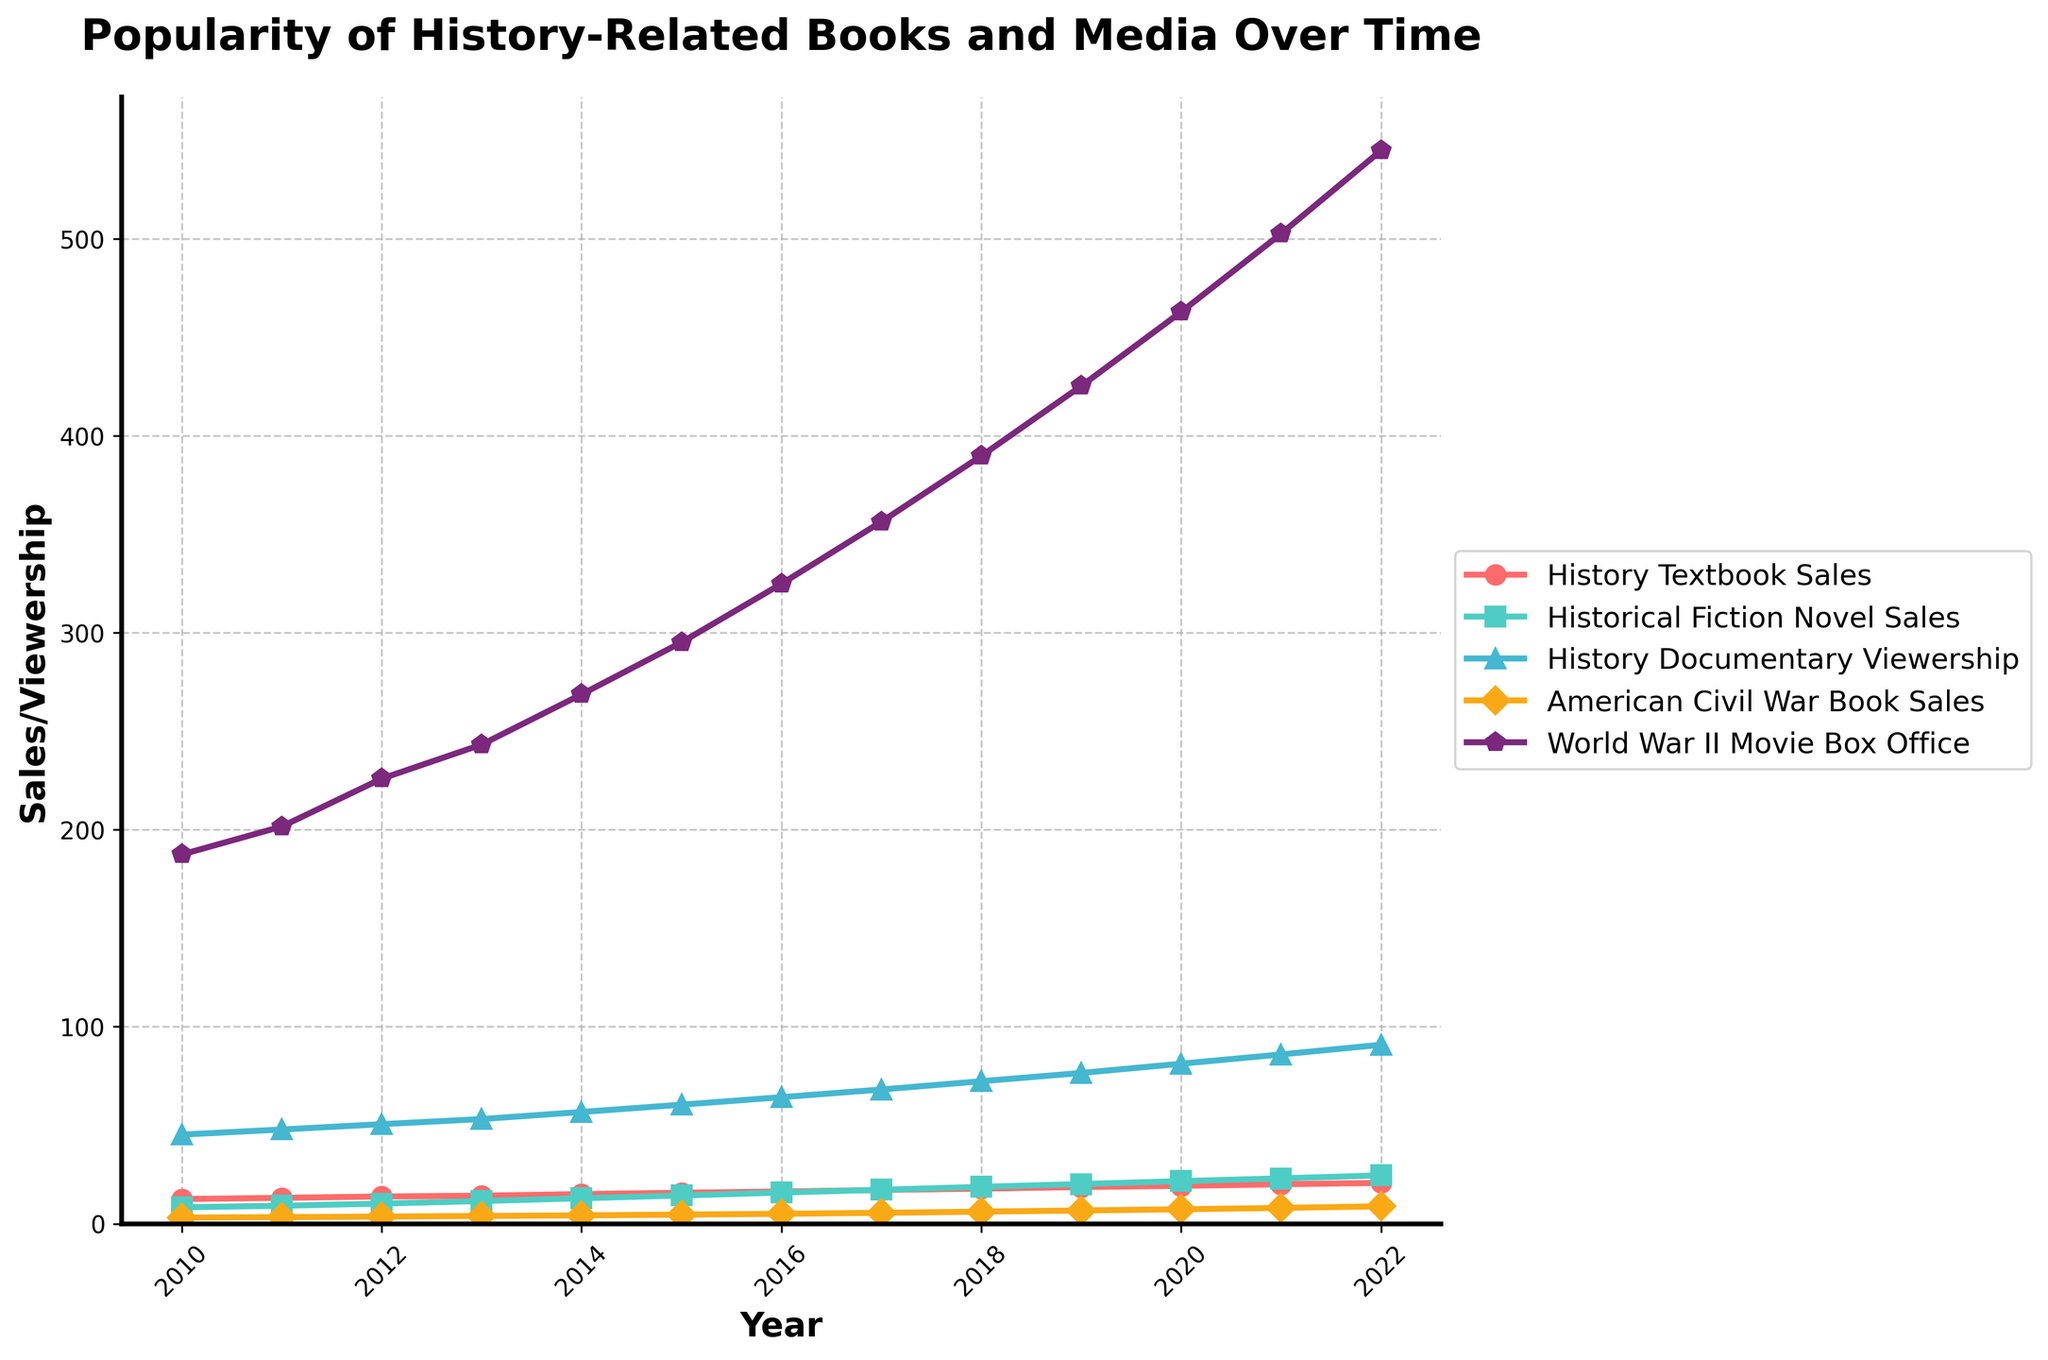What is the trend in history textbook sales from 2010 to 2022? Observing the line representing history textbook sales, from 2010 to 2022, it shows a consistent upward trend. The line starts at 12.5 million in 2010 and rises steadily each year, reaching 20.7 million in 2022.
Answer: Consistent upward trend Which year experienced the highest viewership for history documentaries, and how much was it? By looking at the highest point on the line for history documentary viewership, it is evident that 2022 experienced the highest viewership, with a total of 90.8 million.
Answer: 2022, 90.8 million How do sales of American Civil War books compare to history textbook sales in 2022? In 2022, American Civil War book sales are at 8.8 million while history textbook sales are at 20.7 million. History textbook sales were significantly higher than American Civil War book sales.
Answer: History textbook sales were significantly higher Which type of historical content saw the most growth in popularity from 2010 to 2022? To determine the highest growth, one should look at the difference between the endpoints in each category. World War II movie box office sales grew from 187.4 million USD to 544.7 million USD, which is the highest increase among the categories.
Answer: World War II movie box office sales What is the difference in historical fiction novel sales between the years 2011 and 2019? Looking at the historical fiction novel sales line, the sales were 9.1 million in 2011 and 20.1 million in 2019. The difference is 20.1 - 9.1 = 11 million.
Answer: 11 million By how much did the viewership of history documentaries increase from 2014 to 2020? From 2014 to 2020, history documentary viewership increased from 56.7 million to 81.2 million. The increase is 81.2 - 56.7 = 24.5 million.
Answer: 24.5 million Which type of historical content had the least change in popularity over the years? Observing all the lines, American Civil War book sales had the least change, starting from 3.1 million in 2010 and ending at 8.8 million in 2022.
Answer: American Civil War book sales Among all categories, which experienced the highest viewership/sales in a single year and what was the value? The highest peak among all the lines is for World War II movie box office in 2022, which reached 544.7 million USD.
Answer: World War II movie box office, 544.7 million USD Compare the rate of increase in viewership for history documentaries and sales of historical fiction novels from 2016 to 2018. From 2016 to 2018, history documentary viewership increased from 64.2 million to 72.3 million, an increase of 8.1 million. Historical fiction novel sales increased from 15.8 million to 18.7 million, an increase of 2.9 million. The rate of increase was higher for history documentary viewership.
Answer: History documentary viewership had a higher increase What is the approximate average annual increase in sales of history textbooks from 2010 to 2022? The total increase in history textbook sales from 2010 (12.5 million) to 2022 (20.7 million) is 20.7 - 12.5 = 8.2 million. Over 12 years, the average annual increase is 8.2 / 12 ≈ 0.683 million.
Answer: Approximately 0.683 million 